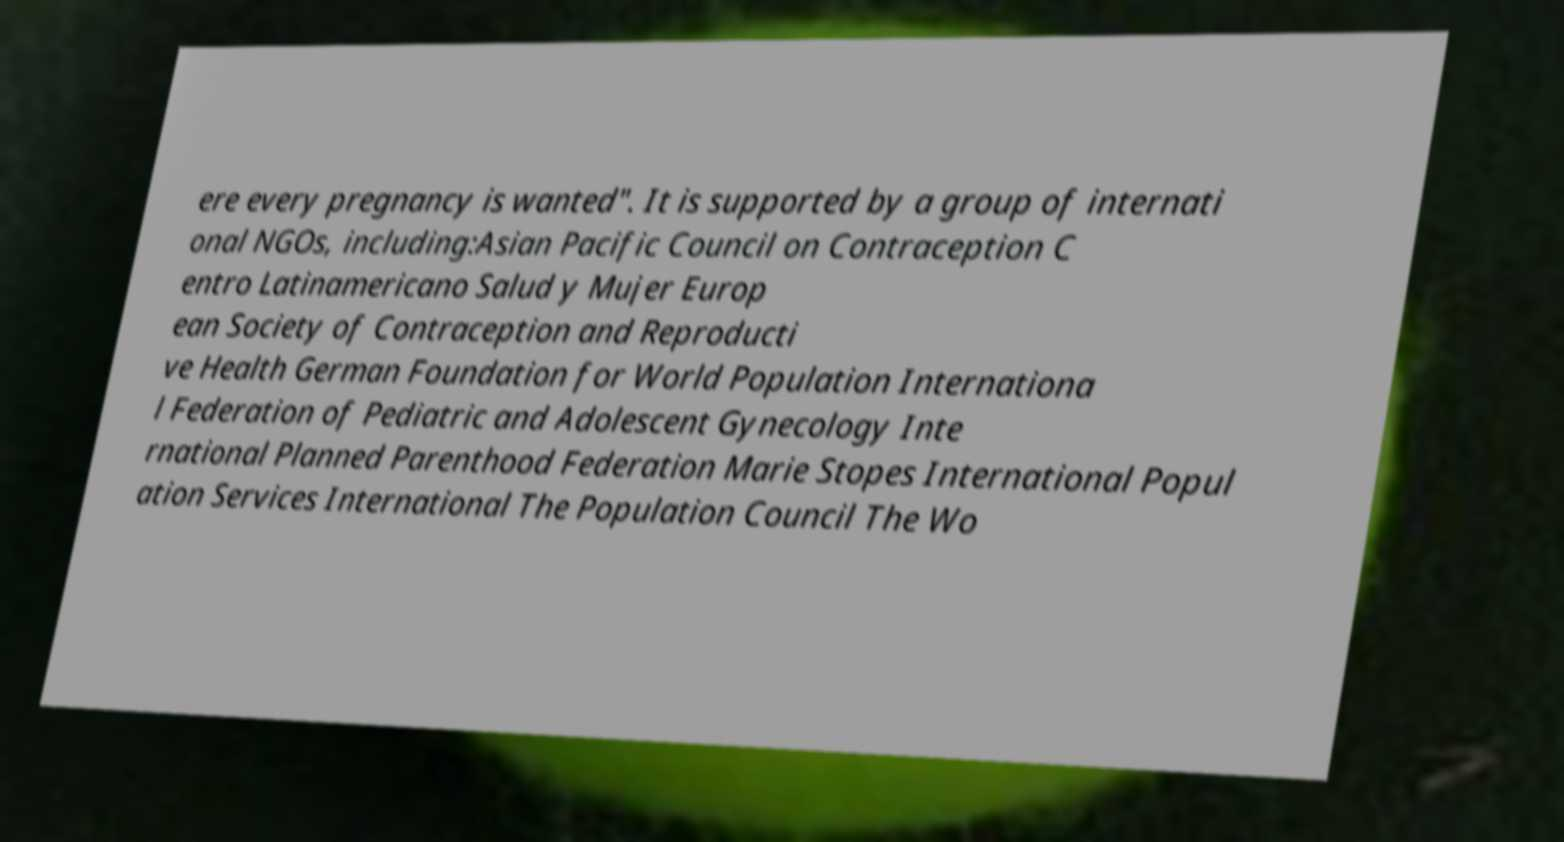I need the written content from this picture converted into text. Can you do that? ere every pregnancy is wanted". It is supported by a group of internati onal NGOs, including:Asian Pacific Council on Contraception C entro Latinamericano Salud y Mujer Europ ean Society of Contraception and Reproducti ve Health German Foundation for World Population Internationa l Federation of Pediatric and Adolescent Gynecology Inte rnational Planned Parenthood Federation Marie Stopes International Popul ation Services International The Population Council The Wo 